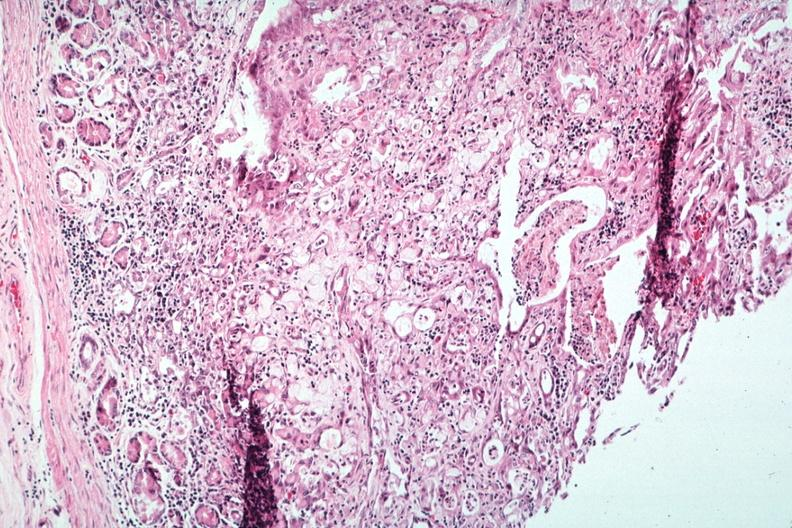does this image show stomach primary?
Answer the question using a single word or phrase. Yes 